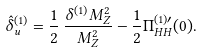<formula> <loc_0><loc_0><loc_500><loc_500>\hat { \delta } _ { u } ^ { ( 1 ) } = \frac { 1 } { 2 } \, \frac { \delta ^ { ( 1 ) } M _ { Z } ^ { 2 } } { M _ { Z } ^ { 2 } } - \frac { 1 } { 2 } \Pi _ { H H } ^ { ( 1 ) \prime } ( 0 ) .</formula> 